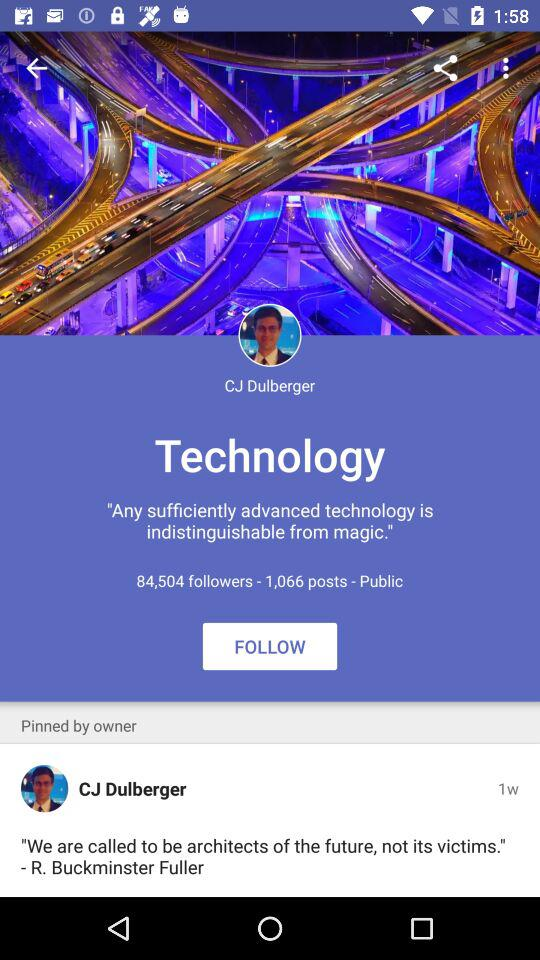What is the login name? The login name is CJ Dulberger. 